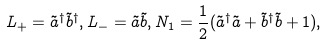<formula> <loc_0><loc_0><loc_500><loc_500>L _ { + } = \tilde { a } ^ { \dag } \tilde { b } ^ { \dag } , L _ { - } = \tilde { a } \tilde { b } , N _ { 1 } = \frac { 1 } { 2 } ( \tilde { a } ^ { \dag } \tilde { a } + \tilde { b } ^ { \dag } \tilde { b } + 1 ) ,</formula> 